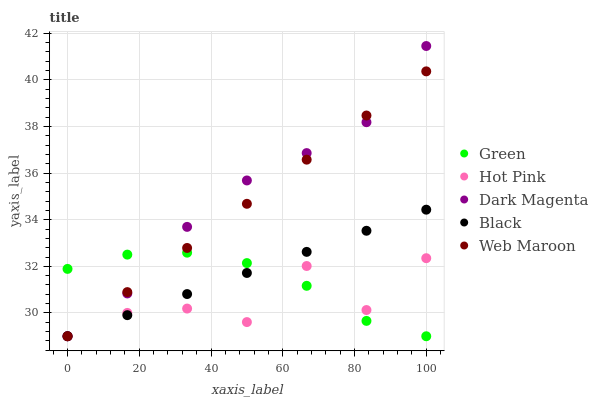Does Hot Pink have the minimum area under the curve?
Answer yes or no. Yes. Does Dark Magenta have the maximum area under the curve?
Answer yes or no. Yes. Does Green have the minimum area under the curve?
Answer yes or no. No. Does Green have the maximum area under the curve?
Answer yes or no. No. Is Web Maroon the smoothest?
Answer yes or no. Yes. Is Hot Pink the roughest?
Answer yes or no. Yes. Is Green the smoothest?
Answer yes or no. No. Is Green the roughest?
Answer yes or no. No. Does Black have the lowest value?
Answer yes or no. Yes. Does Dark Magenta have the highest value?
Answer yes or no. Yes. Does Green have the highest value?
Answer yes or no. No. Does Web Maroon intersect Black?
Answer yes or no. Yes. Is Web Maroon less than Black?
Answer yes or no. No. Is Web Maroon greater than Black?
Answer yes or no. No. 